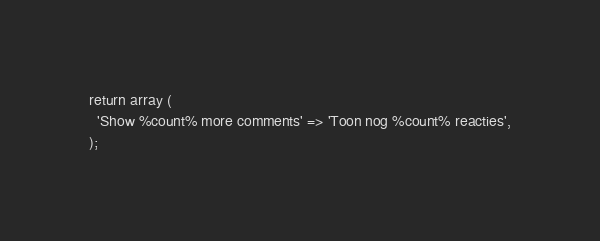Convert code to text. <code><loc_0><loc_0><loc_500><loc_500><_PHP_>return array (
  'Show %count% more comments' => 'Toon nog %count% reacties',
);
</code> 